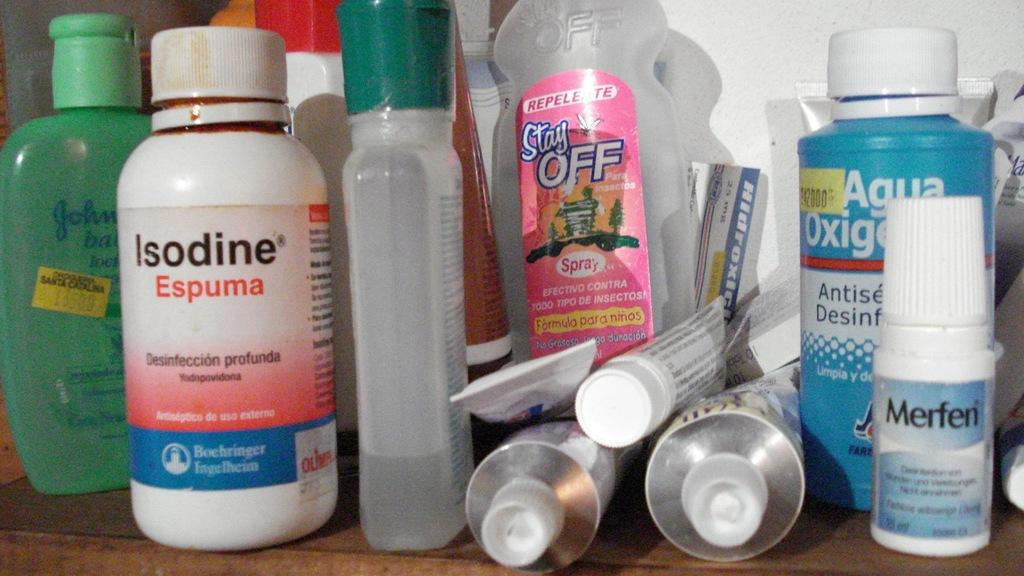<image>
Provide a brief description of the given image. Multiple health products including Isodine Espuma, Stay Off, and Merfen are sitting on a wooden surface. 